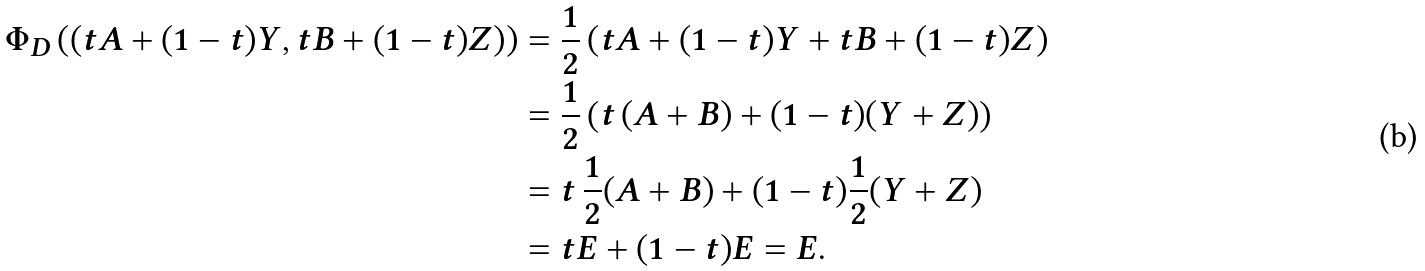<formula> <loc_0><loc_0><loc_500><loc_500>\Phi _ { D } \left ( \left ( t A + ( 1 - t ) Y , t B + ( 1 - t ) Z \right ) \right ) & = \frac { 1 } { 2 } \left ( t A + ( 1 - t ) Y + t B + ( 1 - t ) Z \right ) \\ & = \frac { 1 } { 2 } \left ( t \, ( A + B ) + ( 1 - t ) ( Y + Z ) \right ) \\ & = t \, \frac { 1 } { 2 } ( A + B ) + ( 1 - t ) \frac { 1 } { 2 } ( Y + Z ) \\ & = t E + ( 1 - t ) E = E .</formula> 